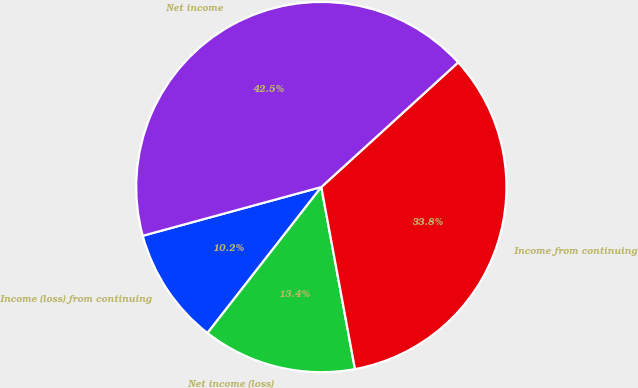Convert chart. <chart><loc_0><loc_0><loc_500><loc_500><pie_chart><fcel>Income (loss) from continuing<fcel>Net income (loss)<fcel>Income from continuing<fcel>Net income<nl><fcel>10.22%<fcel>13.45%<fcel>33.85%<fcel>42.48%<nl></chart> 